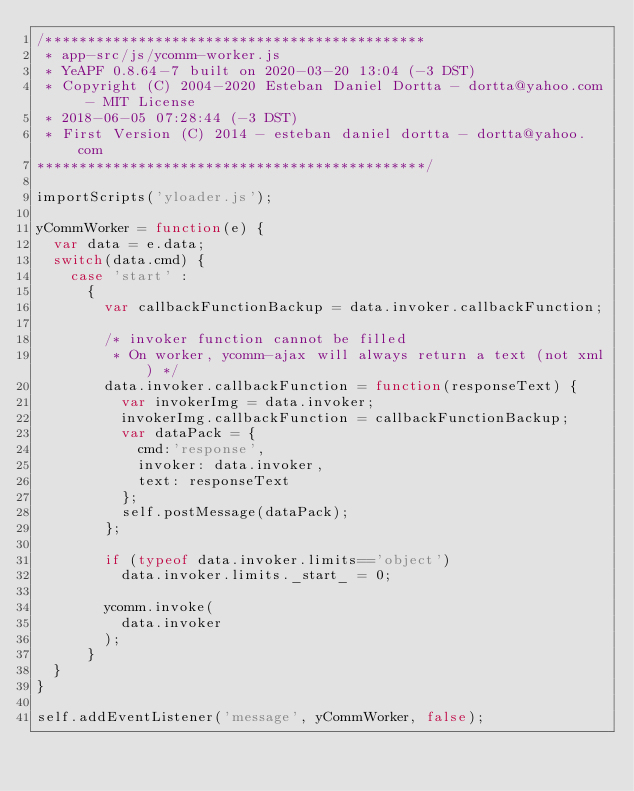Convert code to text. <code><loc_0><loc_0><loc_500><loc_500><_JavaScript_>/*********************************************
 * app-src/js/ycomm-worker.js
 * YeAPF 0.8.64-7 built on 2020-03-20 13:04 (-3 DST)
 * Copyright (C) 2004-2020 Esteban Daniel Dortta - dortta@yahoo.com - MIT License
 * 2018-06-05 07:28:44 (-3 DST)
 * First Version (C) 2014 - esteban daniel dortta - dortta@yahoo.com
**********************************************/

importScripts('yloader.js');

yCommWorker = function(e) {
  var data = e.data;
  switch(data.cmd) {
    case 'start' :
      {
        var callbackFunctionBackup = data.invoker.callbackFunction;

        /* invoker function cannot be filled
         * On worker, ycomm-ajax will always return a text (not xml) */
        data.invoker.callbackFunction = function(responseText) {
          var invokerImg = data.invoker;
          invokerImg.callbackFunction = callbackFunctionBackup;
          var dataPack = {
            cmd:'response',
            invoker: data.invoker,
            text: responseText
          };
          self.postMessage(dataPack);
        };

        if (typeof data.invoker.limits=='object')
          data.invoker.limits._start_ = 0;

        ycomm.invoke(
          data.invoker
        );
      }
  }
}

self.addEventListener('message', yCommWorker, false);
</code> 